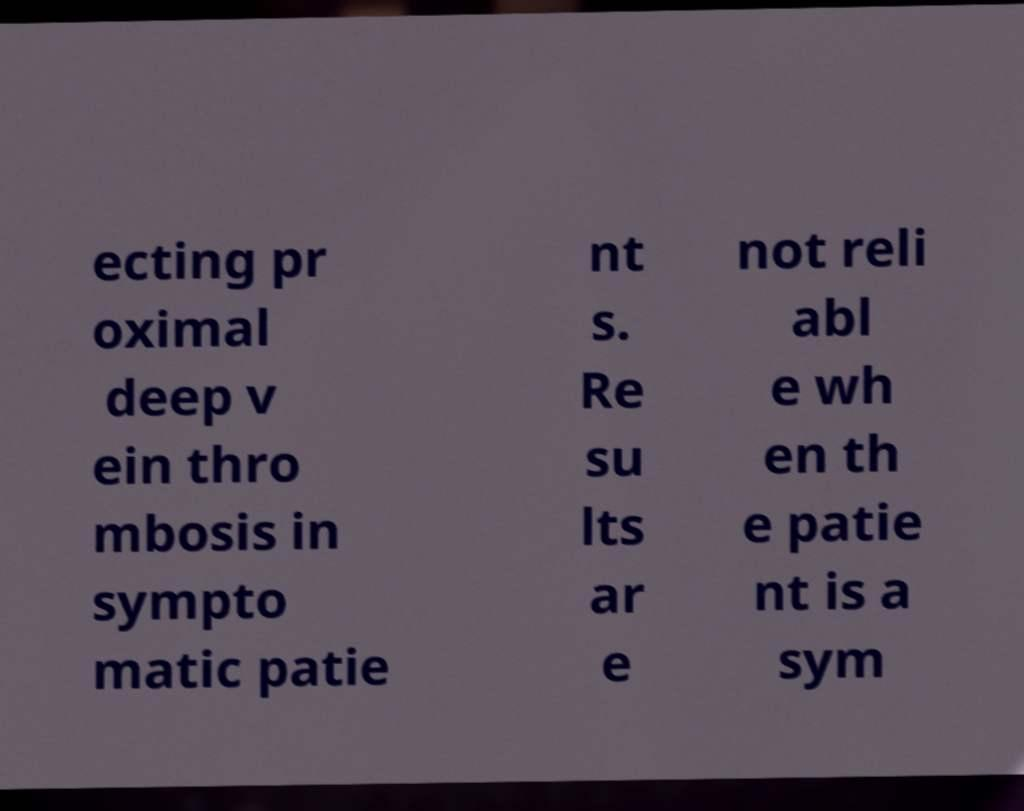For documentation purposes, I need the text within this image transcribed. Could you provide that? ecting pr oximal deep v ein thro mbosis in sympto matic patie nt s. Re su lts ar e not reli abl e wh en th e patie nt is a sym 